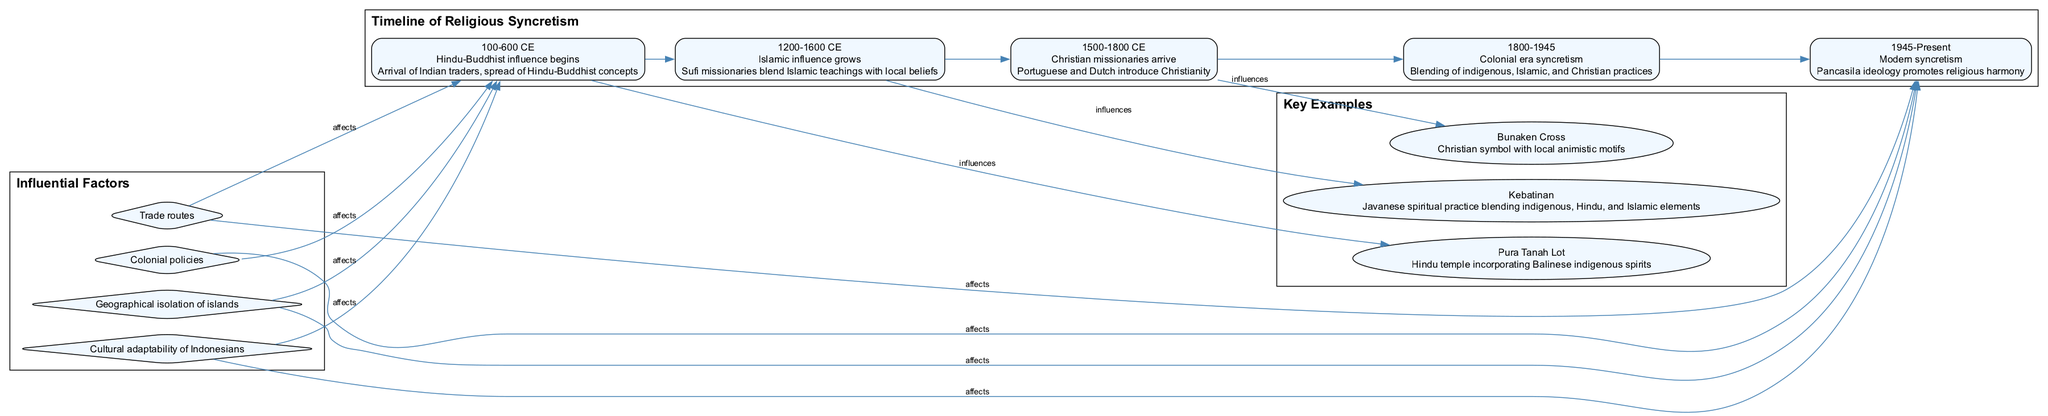What is the first event in the timeline? The first event listed in the timeline is "Hindu-Buddhist influence begins." This is determined by looking at the first node in the timeline section of the diagram, which shows the date range of 100-600 CE and details about the arrival of Indian traders and the spread of concepts.
Answer: Hindu-Buddhist influence begins How many key examples are presented in the diagram? The diagram includes three key examples which can be counted in the 'Key Examples' section. By observing the individual nodes for each example, it is clear there are three distinct entries.
Answer: 3 Which event does the Kebatinan example influence? The diagram indicates that the Kebatinan example is influenced by the event "Islamic influence grows." By following the edges from event 1 to example 0, we see the direct influence relationship established in the diagram.
Answer: Islamic influence grows What ideology promotes religious harmony in modern Indonesia? The diagram specifies that "Pancasila ideology promotes religious harmony." This statement is found in the last event of the timeline, from 1945 to Present, showing the evolution of societal norms in Indonesia.
Answer: Pancasila Name one influential factor that affects the events in the timeline. There are multiple influential factors presented in the diagram; one of them is "Trade routes." This can be identified in the "Influential Factors" section where each factor is represented as nodes bound to relevant events in the timeline.
Answer: Trade routes Which example incorporates Balinese indigenous spirits? The diagram points out that "Pura Tanah Lot" incorporates Balinese indigenous spirits. This information is specified in the node corresponding to this key example in the 'Key Examples' section of the diagram.
Answer: Pura Tanah Lot What is the date range of the colonial era syncretism event? The date range of the event "Colonial era syncretism" in the timeline is from 1800 to 1945. This can be found directly in the timeline segment of the diagram under that specific event.
Answer: 1800-1945 How does the geographical isolation of islands affect the events in the timeline? The diagram illustrates that "Geographical isolation of islands" affects both early and modern periods of religious syncretism. By following the connections from this influential factor, we see it is linked to both event 0 and event 4.
Answer: Affects early and modern periods 